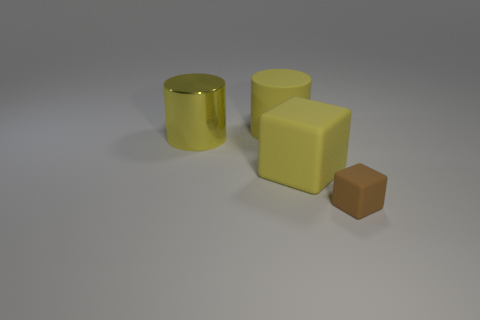What can you infer about the lighting and the environment where these objects are placed? The shadows cast by the objects are soft and diffused, implying that the light source is not extremely close or overly intense. The lack of any distinguishing features in the background and the uniformity of the surface suggest that this image was taken in a controlled, neutral environment, such as a photography studio with a lightbox set-up, to minimize reflections and ensure consistent lighting. 